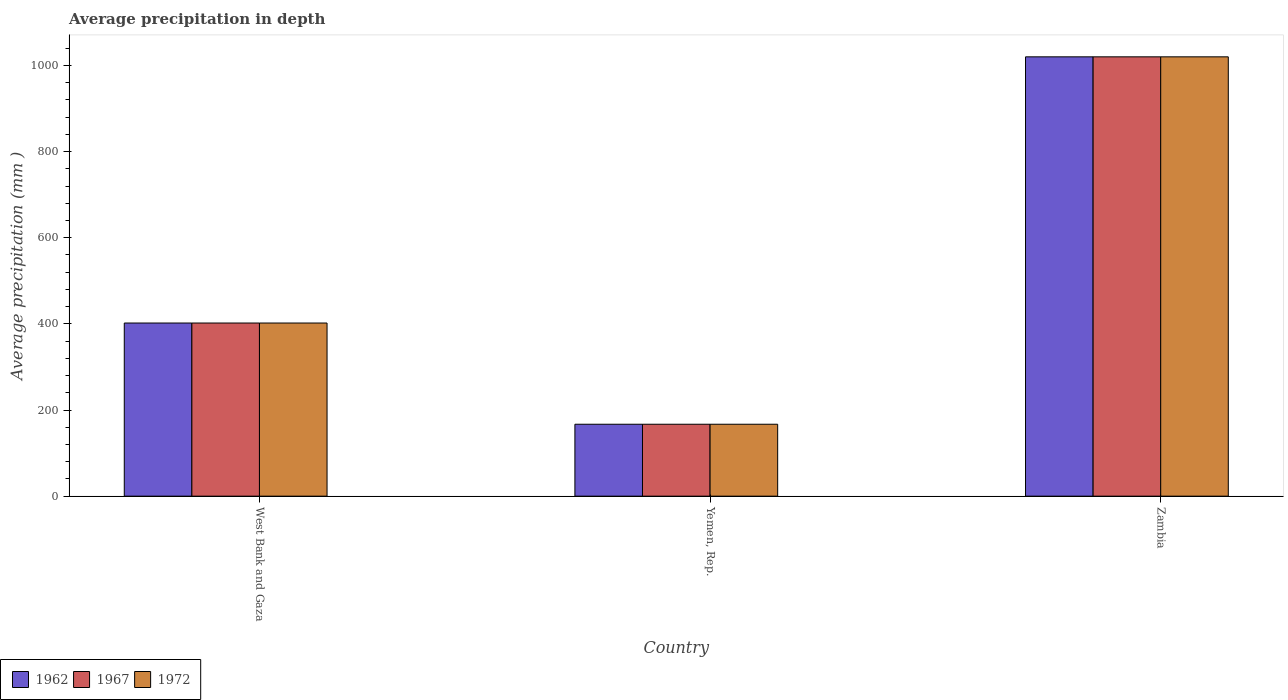How many different coloured bars are there?
Give a very brief answer. 3. How many bars are there on the 1st tick from the right?
Offer a very short reply. 3. What is the label of the 1st group of bars from the left?
Keep it short and to the point. West Bank and Gaza. In how many cases, is the number of bars for a given country not equal to the number of legend labels?
Keep it short and to the point. 0. What is the average precipitation in 1972 in Yemen, Rep.?
Ensure brevity in your answer.  167. Across all countries, what is the maximum average precipitation in 1962?
Your response must be concise. 1020. Across all countries, what is the minimum average precipitation in 1967?
Offer a terse response. 167. In which country was the average precipitation in 1962 maximum?
Offer a terse response. Zambia. In which country was the average precipitation in 1972 minimum?
Provide a short and direct response. Yemen, Rep. What is the total average precipitation in 1962 in the graph?
Make the answer very short. 1589. What is the difference between the average precipitation in 1972 in West Bank and Gaza and that in Yemen, Rep.?
Keep it short and to the point. 235. What is the difference between the average precipitation in 1962 in Yemen, Rep. and the average precipitation in 1972 in Zambia?
Your answer should be compact. -853. What is the average average precipitation in 1962 per country?
Offer a very short reply. 529.67. What is the difference between the average precipitation of/in 1967 and average precipitation of/in 1972 in Zambia?
Make the answer very short. 0. In how many countries, is the average precipitation in 1962 greater than 560 mm?
Your response must be concise. 1. What is the ratio of the average precipitation in 1972 in Yemen, Rep. to that in Zambia?
Provide a short and direct response. 0.16. Is the average precipitation in 1972 in Yemen, Rep. less than that in Zambia?
Your answer should be compact. Yes. Is the difference between the average precipitation in 1967 in West Bank and Gaza and Zambia greater than the difference between the average precipitation in 1972 in West Bank and Gaza and Zambia?
Make the answer very short. No. What is the difference between the highest and the second highest average precipitation in 1967?
Your answer should be compact. -618. What is the difference between the highest and the lowest average precipitation in 1972?
Your response must be concise. 853. In how many countries, is the average precipitation in 1962 greater than the average average precipitation in 1962 taken over all countries?
Give a very brief answer. 1. Is the sum of the average precipitation in 1962 in West Bank and Gaza and Yemen, Rep. greater than the maximum average precipitation in 1967 across all countries?
Ensure brevity in your answer.  No. What does the 3rd bar from the left in West Bank and Gaza represents?
Your answer should be compact. 1972. What does the 1st bar from the right in Yemen, Rep. represents?
Your answer should be very brief. 1972. How many bars are there?
Make the answer very short. 9. Does the graph contain any zero values?
Your answer should be very brief. No. How many legend labels are there?
Offer a very short reply. 3. What is the title of the graph?
Provide a succinct answer. Average precipitation in depth. Does "1997" appear as one of the legend labels in the graph?
Provide a succinct answer. No. What is the label or title of the X-axis?
Offer a very short reply. Country. What is the label or title of the Y-axis?
Provide a short and direct response. Average precipitation (mm ). What is the Average precipitation (mm ) in 1962 in West Bank and Gaza?
Provide a short and direct response. 402. What is the Average precipitation (mm ) of 1967 in West Bank and Gaza?
Provide a short and direct response. 402. What is the Average precipitation (mm ) in 1972 in West Bank and Gaza?
Provide a succinct answer. 402. What is the Average precipitation (mm ) in 1962 in Yemen, Rep.?
Give a very brief answer. 167. What is the Average precipitation (mm ) in 1967 in Yemen, Rep.?
Your response must be concise. 167. What is the Average precipitation (mm ) in 1972 in Yemen, Rep.?
Your answer should be very brief. 167. What is the Average precipitation (mm ) in 1962 in Zambia?
Offer a very short reply. 1020. What is the Average precipitation (mm ) of 1967 in Zambia?
Ensure brevity in your answer.  1020. What is the Average precipitation (mm ) of 1972 in Zambia?
Offer a terse response. 1020. Across all countries, what is the maximum Average precipitation (mm ) of 1962?
Your answer should be compact. 1020. Across all countries, what is the maximum Average precipitation (mm ) in 1967?
Your answer should be compact. 1020. Across all countries, what is the maximum Average precipitation (mm ) of 1972?
Keep it short and to the point. 1020. Across all countries, what is the minimum Average precipitation (mm ) in 1962?
Provide a short and direct response. 167. Across all countries, what is the minimum Average precipitation (mm ) of 1967?
Give a very brief answer. 167. Across all countries, what is the minimum Average precipitation (mm ) in 1972?
Your answer should be very brief. 167. What is the total Average precipitation (mm ) in 1962 in the graph?
Keep it short and to the point. 1589. What is the total Average precipitation (mm ) of 1967 in the graph?
Make the answer very short. 1589. What is the total Average precipitation (mm ) of 1972 in the graph?
Ensure brevity in your answer.  1589. What is the difference between the Average precipitation (mm ) of 1962 in West Bank and Gaza and that in Yemen, Rep.?
Make the answer very short. 235. What is the difference between the Average precipitation (mm ) in 1967 in West Bank and Gaza and that in Yemen, Rep.?
Your answer should be compact. 235. What is the difference between the Average precipitation (mm ) of 1972 in West Bank and Gaza and that in Yemen, Rep.?
Give a very brief answer. 235. What is the difference between the Average precipitation (mm ) in 1962 in West Bank and Gaza and that in Zambia?
Give a very brief answer. -618. What is the difference between the Average precipitation (mm ) in 1967 in West Bank and Gaza and that in Zambia?
Keep it short and to the point. -618. What is the difference between the Average precipitation (mm ) of 1972 in West Bank and Gaza and that in Zambia?
Offer a very short reply. -618. What is the difference between the Average precipitation (mm ) in 1962 in Yemen, Rep. and that in Zambia?
Provide a short and direct response. -853. What is the difference between the Average precipitation (mm ) of 1967 in Yemen, Rep. and that in Zambia?
Provide a succinct answer. -853. What is the difference between the Average precipitation (mm ) in 1972 in Yemen, Rep. and that in Zambia?
Ensure brevity in your answer.  -853. What is the difference between the Average precipitation (mm ) of 1962 in West Bank and Gaza and the Average precipitation (mm ) of 1967 in Yemen, Rep.?
Make the answer very short. 235. What is the difference between the Average precipitation (mm ) in 1962 in West Bank and Gaza and the Average precipitation (mm ) in 1972 in Yemen, Rep.?
Offer a terse response. 235. What is the difference between the Average precipitation (mm ) in 1967 in West Bank and Gaza and the Average precipitation (mm ) in 1972 in Yemen, Rep.?
Keep it short and to the point. 235. What is the difference between the Average precipitation (mm ) of 1962 in West Bank and Gaza and the Average precipitation (mm ) of 1967 in Zambia?
Provide a succinct answer. -618. What is the difference between the Average precipitation (mm ) in 1962 in West Bank and Gaza and the Average precipitation (mm ) in 1972 in Zambia?
Offer a very short reply. -618. What is the difference between the Average precipitation (mm ) in 1967 in West Bank and Gaza and the Average precipitation (mm ) in 1972 in Zambia?
Offer a very short reply. -618. What is the difference between the Average precipitation (mm ) of 1962 in Yemen, Rep. and the Average precipitation (mm ) of 1967 in Zambia?
Give a very brief answer. -853. What is the difference between the Average precipitation (mm ) of 1962 in Yemen, Rep. and the Average precipitation (mm ) of 1972 in Zambia?
Your answer should be very brief. -853. What is the difference between the Average precipitation (mm ) of 1967 in Yemen, Rep. and the Average precipitation (mm ) of 1972 in Zambia?
Provide a short and direct response. -853. What is the average Average precipitation (mm ) in 1962 per country?
Offer a terse response. 529.67. What is the average Average precipitation (mm ) of 1967 per country?
Provide a short and direct response. 529.67. What is the average Average precipitation (mm ) in 1972 per country?
Give a very brief answer. 529.67. What is the difference between the Average precipitation (mm ) of 1962 and Average precipitation (mm ) of 1972 in West Bank and Gaza?
Your answer should be very brief. 0. What is the difference between the Average precipitation (mm ) of 1967 and Average precipitation (mm ) of 1972 in West Bank and Gaza?
Make the answer very short. 0. What is the difference between the Average precipitation (mm ) in 1962 and Average precipitation (mm ) in 1972 in Yemen, Rep.?
Your answer should be very brief. 0. What is the ratio of the Average precipitation (mm ) in 1962 in West Bank and Gaza to that in Yemen, Rep.?
Your answer should be compact. 2.41. What is the ratio of the Average precipitation (mm ) in 1967 in West Bank and Gaza to that in Yemen, Rep.?
Provide a short and direct response. 2.41. What is the ratio of the Average precipitation (mm ) in 1972 in West Bank and Gaza to that in Yemen, Rep.?
Keep it short and to the point. 2.41. What is the ratio of the Average precipitation (mm ) in 1962 in West Bank and Gaza to that in Zambia?
Provide a short and direct response. 0.39. What is the ratio of the Average precipitation (mm ) in 1967 in West Bank and Gaza to that in Zambia?
Make the answer very short. 0.39. What is the ratio of the Average precipitation (mm ) in 1972 in West Bank and Gaza to that in Zambia?
Offer a very short reply. 0.39. What is the ratio of the Average precipitation (mm ) of 1962 in Yemen, Rep. to that in Zambia?
Keep it short and to the point. 0.16. What is the ratio of the Average precipitation (mm ) of 1967 in Yemen, Rep. to that in Zambia?
Ensure brevity in your answer.  0.16. What is the ratio of the Average precipitation (mm ) in 1972 in Yemen, Rep. to that in Zambia?
Make the answer very short. 0.16. What is the difference between the highest and the second highest Average precipitation (mm ) in 1962?
Your response must be concise. 618. What is the difference between the highest and the second highest Average precipitation (mm ) of 1967?
Offer a terse response. 618. What is the difference between the highest and the second highest Average precipitation (mm ) in 1972?
Your response must be concise. 618. What is the difference between the highest and the lowest Average precipitation (mm ) of 1962?
Your answer should be very brief. 853. What is the difference between the highest and the lowest Average precipitation (mm ) of 1967?
Your answer should be very brief. 853. What is the difference between the highest and the lowest Average precipitation (mm ) of 1972?
Provide a short and direct response. 853. 